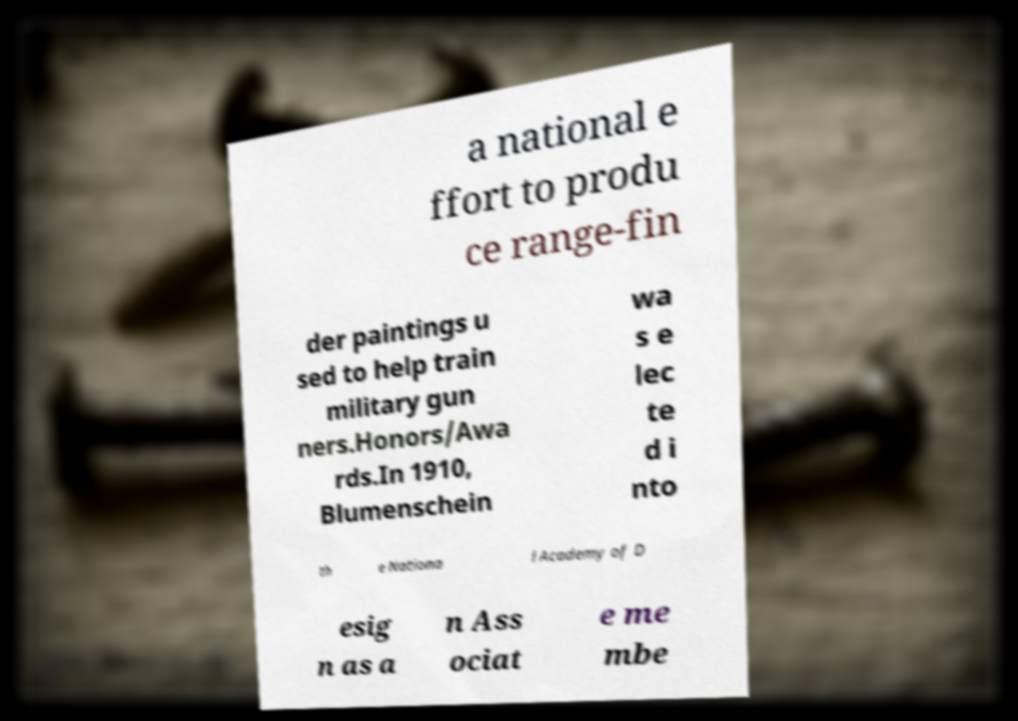Could you assist in decoding the text presented in this image and type it out clearly? a national e ffort to produ ce range-fin der paintings u sed to help train military gun ners.Honors/Awa rds.In 1910, Blumenschein wa s e lec te d i nto th e Nationa l Academy of D esig n as a n Ass ociat e me mbe 